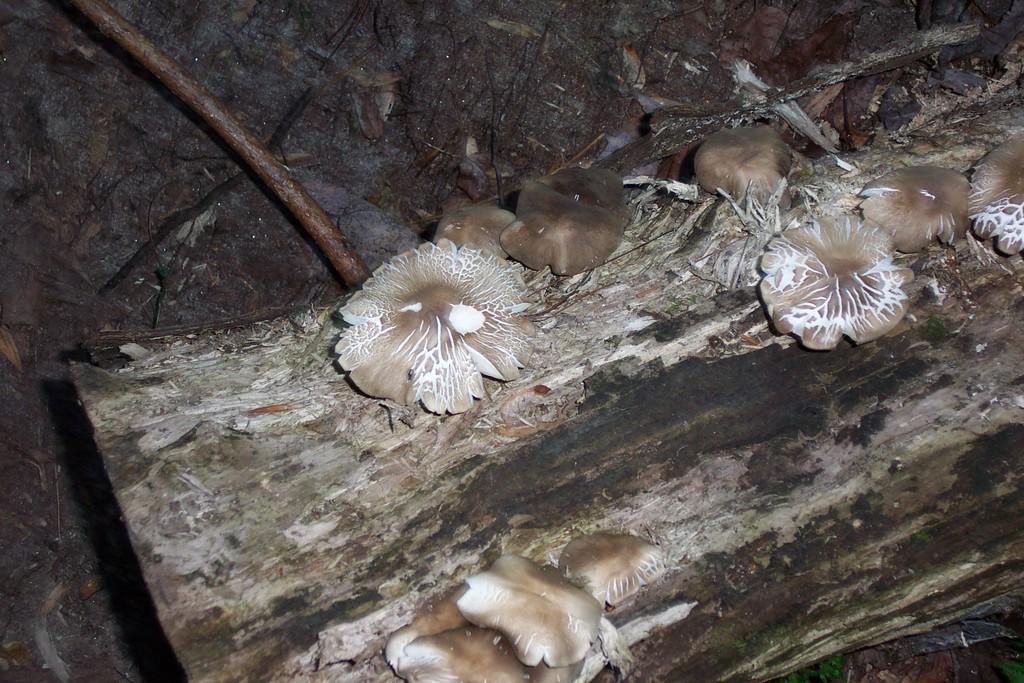How would you summarize this image in a sentence or two? In this image, I think these are the kind of mushrooms, which are on a wooden board. This is a branch. In the background, It looks like a wall. 